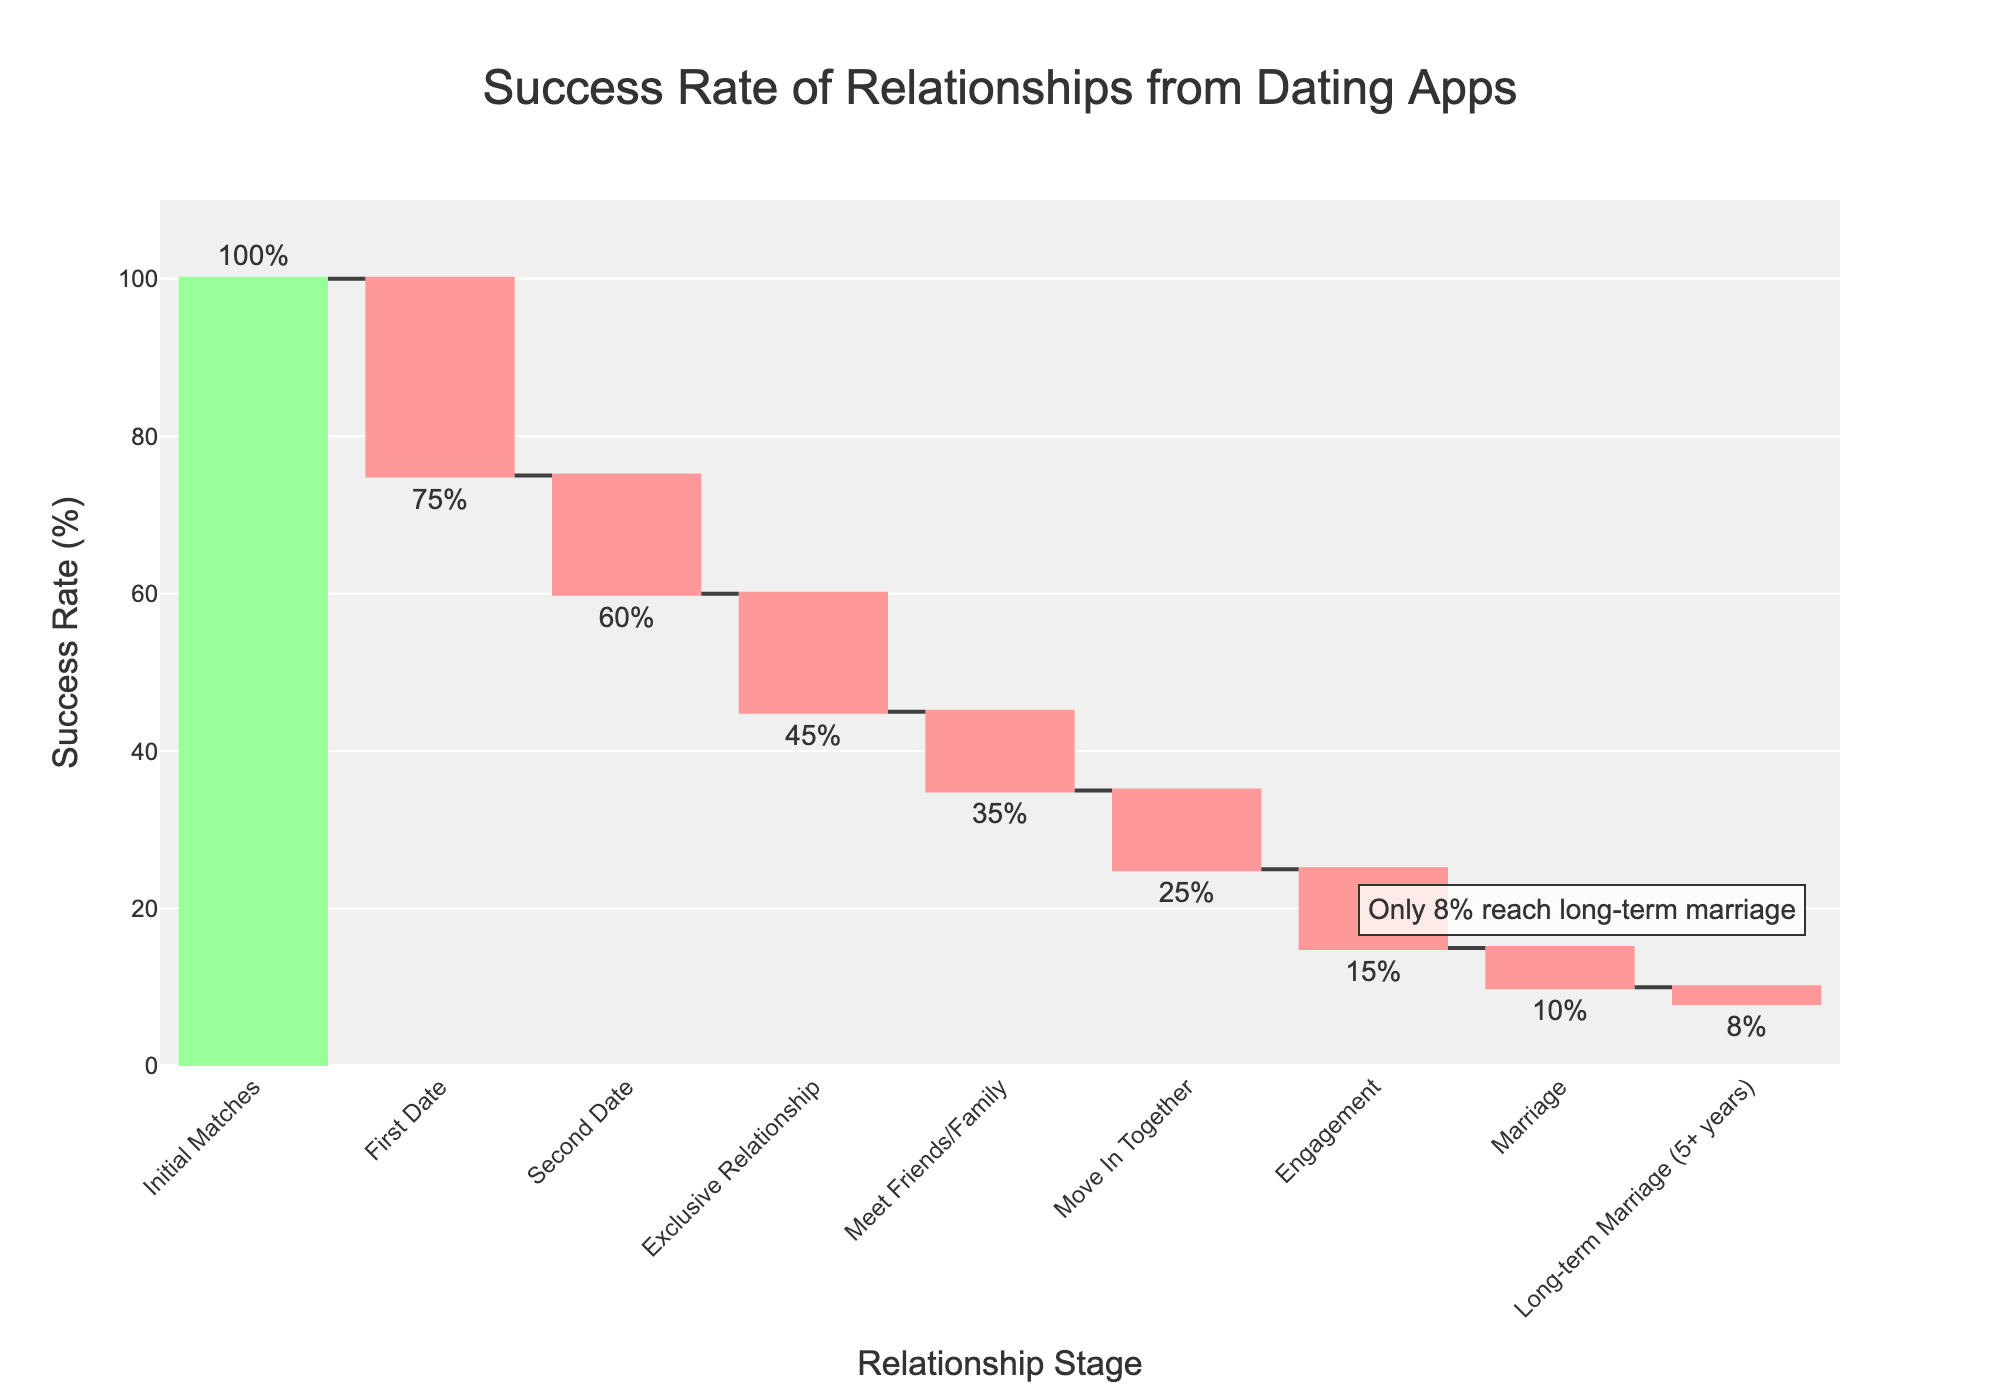What is the title of the chart? The title of the chart is always located at the top of the plot.
Answer: Success Rate of Relationships from Dating Apps How many relationship stages are presented in the chart? By counting the labels on the x-axis, you will find 9 relationship stages listed.
Answer: 9 Which stage shows the drop from 75% to 60% in success rate? Look at the values listed for each stage on the x-axis and identify the transition where the success rate drops from 75% to 60%. This transition happens between "First Date" and "Second Date."
Answer: "First Date" to "Second Date" What percentage of initial matches result in engagement? Starting with 100% initial matches and following the flow through stages, engagement occurs when only 15% succeed.
Answer: 15% What is the difference in success rate between moving in together and long-term marriage? From the y-values, moving in together is 25%, and long-term marriage is 8%; their difference is 25% - 8% = 17%.
Answer: 17% What stage has the highest drop in success rate? The largest drop is found by looking for the biggest negative change in successive stages. The largest drop is from "Initial Matches" to "First Date" (100% - 75% = 25%).
Answer: Initial Matches to First Date How does the success rate change from engagement to marriage? The success rate changes from 15% at the engagement stage to 10% at the marriage stage, resulting in a decrease of 15% - 10% = 5%.
Answer: 5% Which stage has the smallest change in success rate? Comparing changes between each stage, the smallest positive change occurs between "Marriage" and "Long-term Marriage" where it decreases by only 2%.
Answer: Marriage to Long-term Marriage What annotation is included in the figure and where is it located? The annotation stating "Only 8% reach long-term marriage" is included in the bottom right area within the plot.
Answer: Only 8% reach long-term marriage, bottom right Which stages use a decrease in marker color, and what is the color? All stages showing a decrease in success rate are colored in red, such as the transition from "Initial Matches" to "First Date", and others showing a reduction.
Answer: Red 